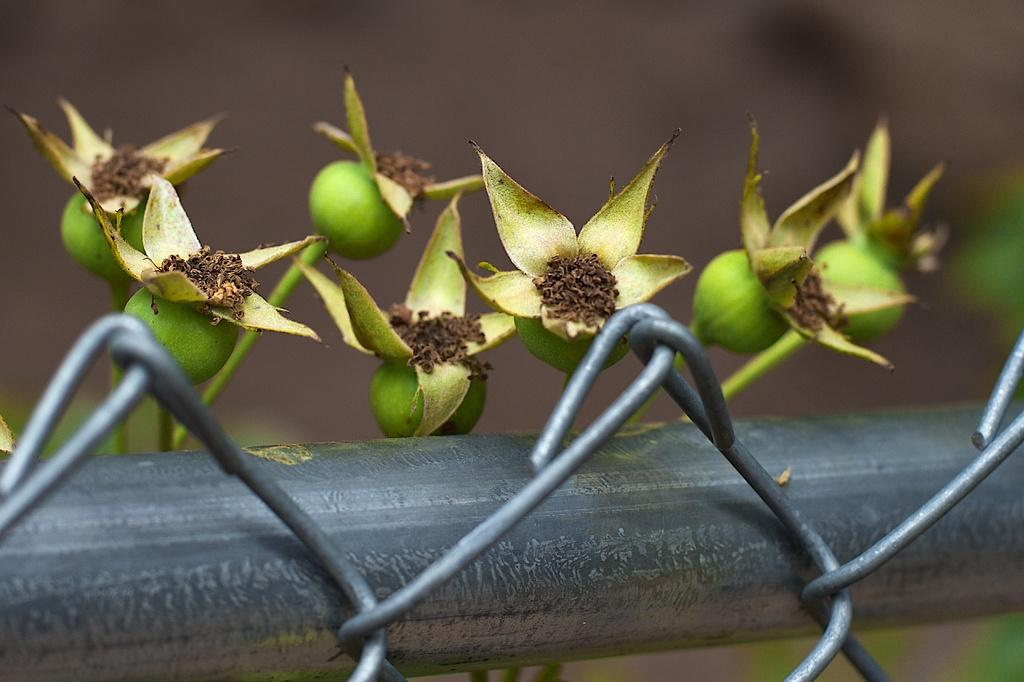What color are the fruits in the image? The fruits in the image are green. What structure can be seen at the bottom of the image? There is a fence visible at the bottom of the image. How would you describe the background of the image? The background of the image is blurred. What type of mint is growing near the fence in the image? There is no mint visible in the image; it only features green color fruits and a fence. 